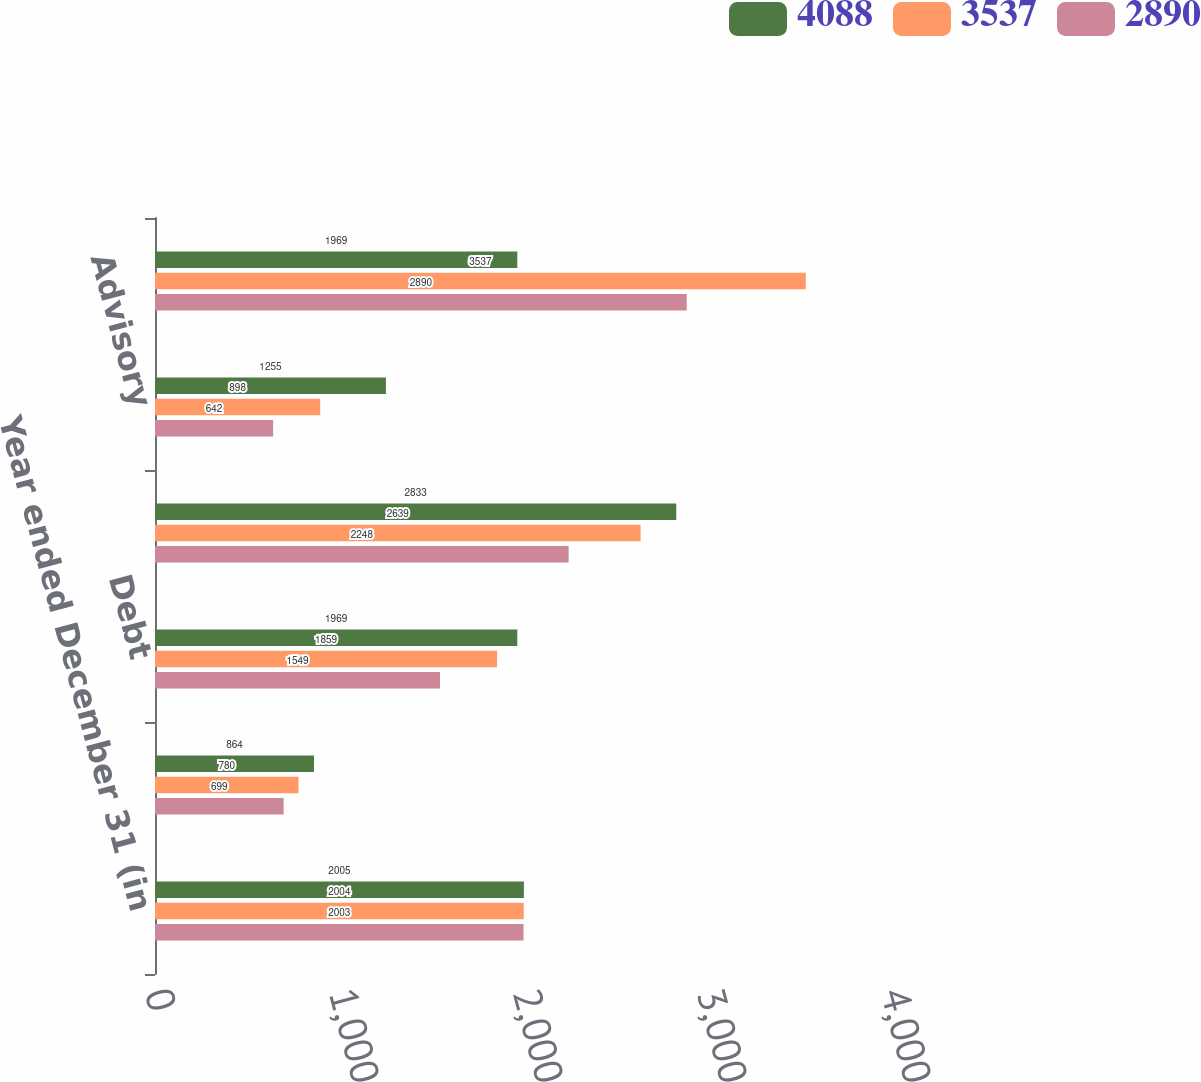Convert chart. <chart><loc_0><loc_0><loc_500><loc_500><stacked_bar_chart><ecel><fcel>Year ended December 31 (in<fcel>Equity<fcel>Debt<fcel>Total Underwriting<fcel>Advisory<fcel>Total<nl><fcel>4088<fcel>2005<fcel>864<fcel>1969<fcel>2833<fcel>1255<fcel>1969<nl><fcel>3537<fcel>2004<fcel>780<fcel>1859<fcel>2639<fcel>898<fcel>3537<nl><fcel>2890<fcel>2003<fcel>699<fcel>1549<fcel>2248<fcel>642<fcel>2890<nl></chart> 